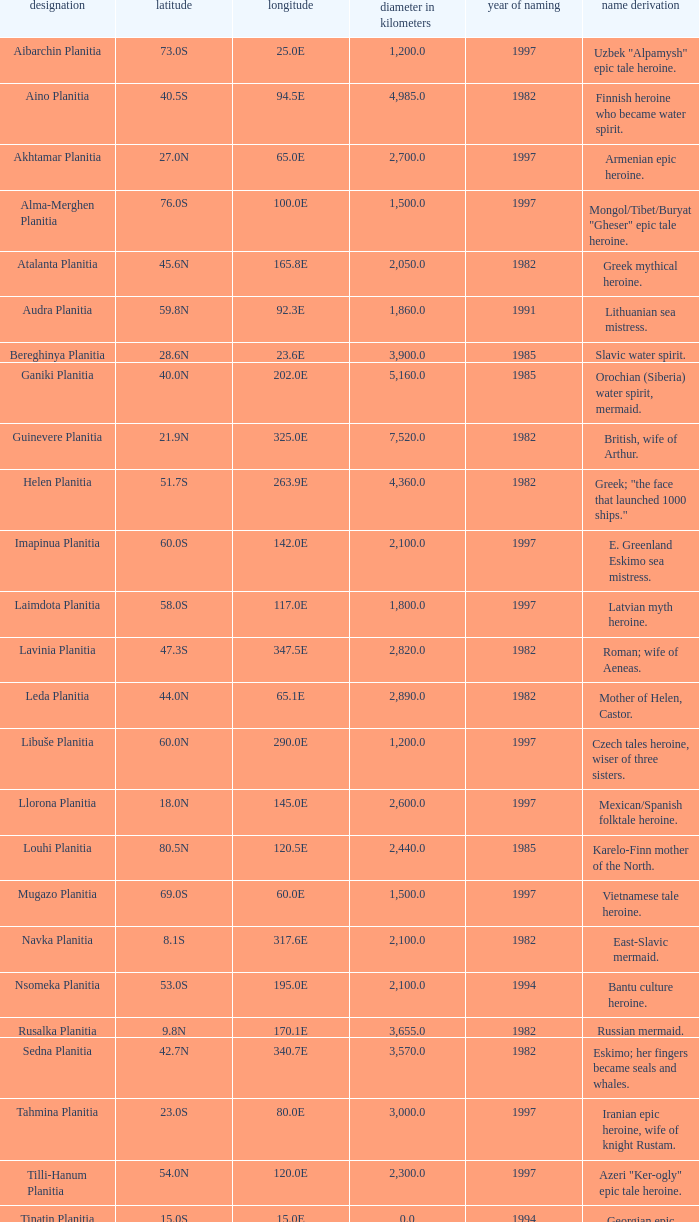What is the diameter (km) of feature of latitude 40.5s 4985.0. 